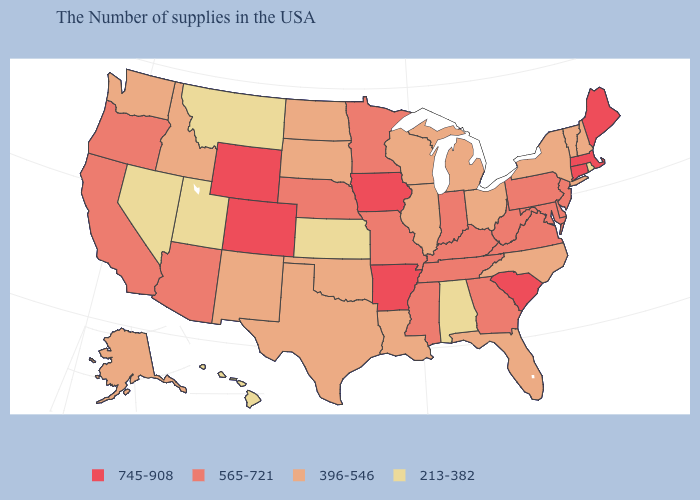What is the highest value in states that border Kansas?
Give a very brief answer. 745-908. Which states have the lowest value in the USA?
Short answer required. Rhode Island, Alabama, Kansas, Utah, Montana, Nevada, Hawaii. What is the lowest value in the USA?
Quick response, please. 213-382. What is the value of North Carolina?
Write a very short answer. 396-546. Does Connecticut have the same value as Nebraska?
Concise answer only. No. Name the states that have a value in the range 565-721?
Short answer required. New Jersey, Delaware, Maryland, Pennsylvania, Virginia, West Virginia, Georgia, Kentucky, Indiana, Tennessee, Mississippi, Missouri, Minnesota, Nebraska, Arizona, California, Oregon. Does South Carolina have the lowest value in the USA?
Concise answer only. No. Name the states that have a value in the range 745-908?
Quick response, please. Maine, Massachusetts, Connecticut, South Carolina, Arkansas, Iowa, Wyoming, Colorado. Name the states that have a value in the range 213-382?
Short answer required. Rhode Island, Alabama, Kansas, Utah, Montana, Nevada, Hawaii. What is the value of Arkansas?
Be succinct. 745-908. Name the states that have a value in the range 565-721?
Quick response, please. New Jersey, Delaware, Maryland, Pennsylvania, Virginia, West Virginia, Georgia, Kentucky, Indiana, Tennessee, Mississippi, Missouri, Minnesota, Nebraska, Arizona, California, Oregon. What is the value of Maryland?
Answer briefly. 565-721. Among the states that border Washington , which have the lowest value?
Keep it brief. Idaho. What is the lowest value in the USA?
Concise answer only. 213-382. Name the states that have a value in the range 745-908?
Write a very short answer. Maine, Massachusetts, Connecticut, South Carolina, Arkansas, Iowa, Wyoming, Colorado. 